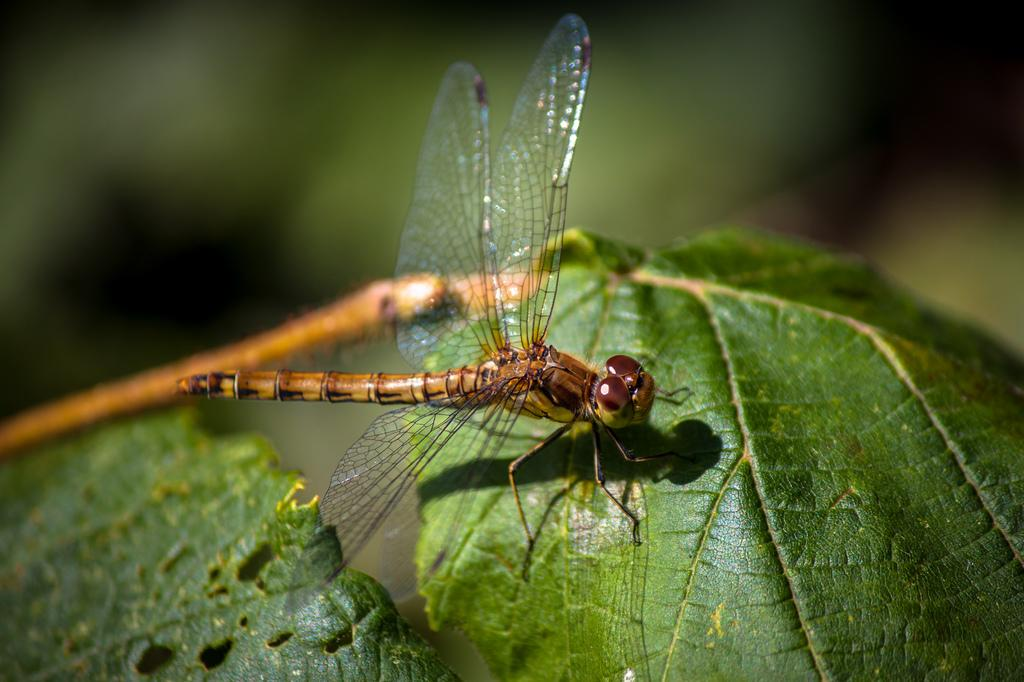What insect is present on a leaf in the image? There is a dragonfly on a leaf in the image. How many leaves are on the stem in the image? There are two leaves on a stem in the image. Can you describe the background of the image? The background of the image is blurry. What type of creature is being attracted to the pump in the image? There is no pump present in the image, so it is not possible to determine what type of creature might be attracted to it. 